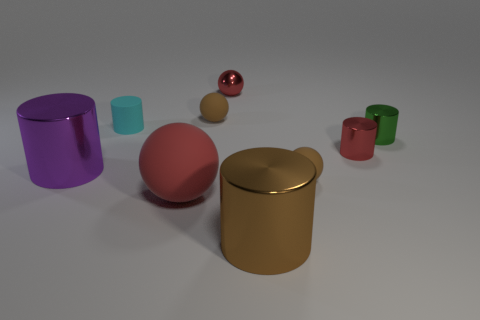Is there anything else of the same color as the large matte object? Yes, there is a small glossy sphere that shares the same hue as the large matte object to the right. 